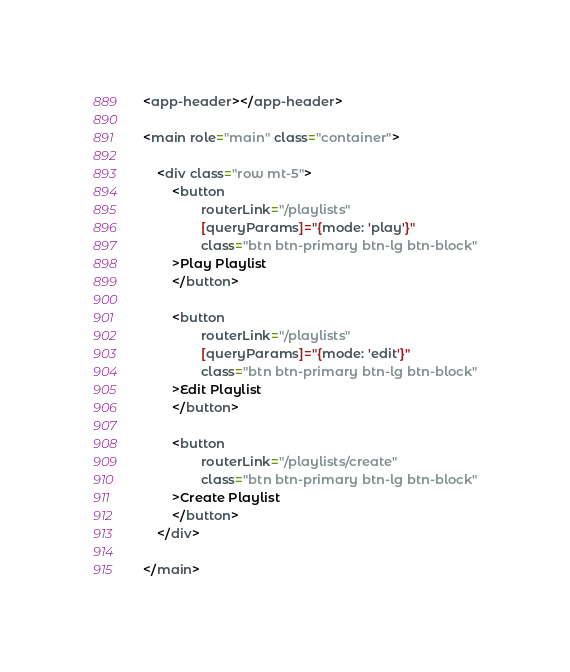Convert code to text. <code><loc_0><loc_0><loc_500><loc_500><_HTML_><app-header></app-header>

<main role="main" class="container">

    <div class="row mt-5">
        <button
                routerLink="/playlists"
                [queryParams]="{mode: 'play'}"
                class="btn btn-primary btn-lg btn-block"
        >Play Playlist
        </button>

        <button
                routerLink="/playlists"
                [queryParams]="{mode: 'edit'}"
                class="btn btn-primary btn-lg btn-block"
        >Edit Playlist
        </button>

        <button
                routerLink="/playlists/create"
                class="btn btn-primary btn-lg btn-block"
        >Create Playlist
        </button>
    </div>

</main>
</code> 